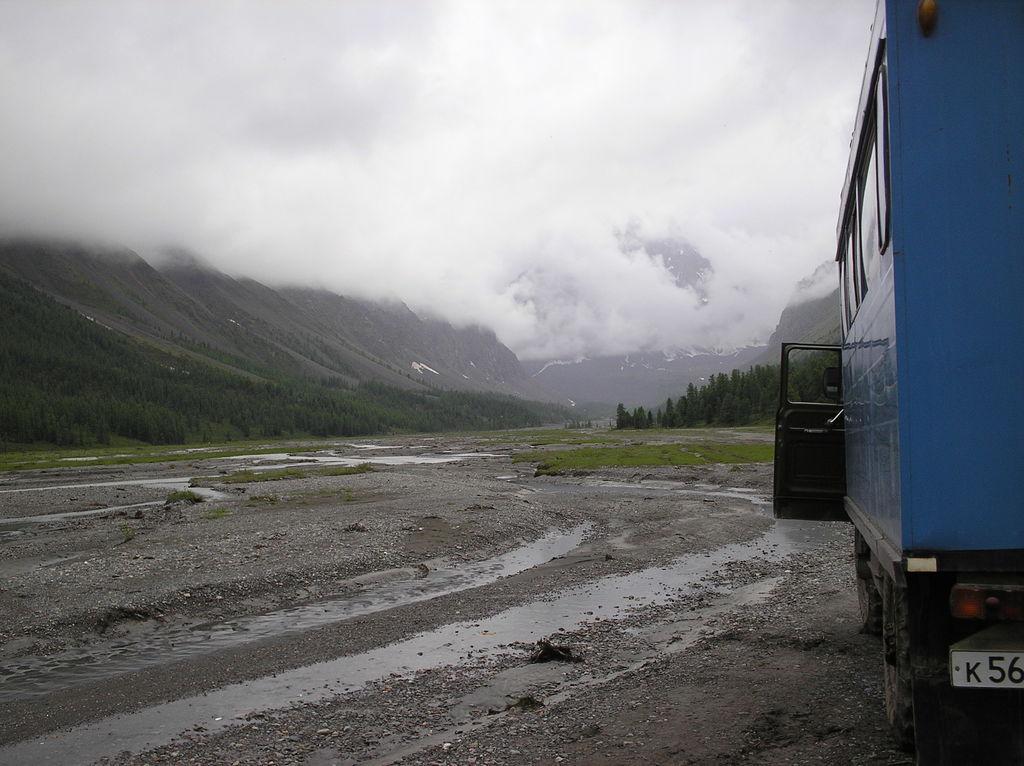How would you summarize this image in a sentence or two? In the foreground, I can see a vehicle on the road and grass. In the background, I can see trees, mountains, fog and the sky. This picture might be taken in a rainy day. 